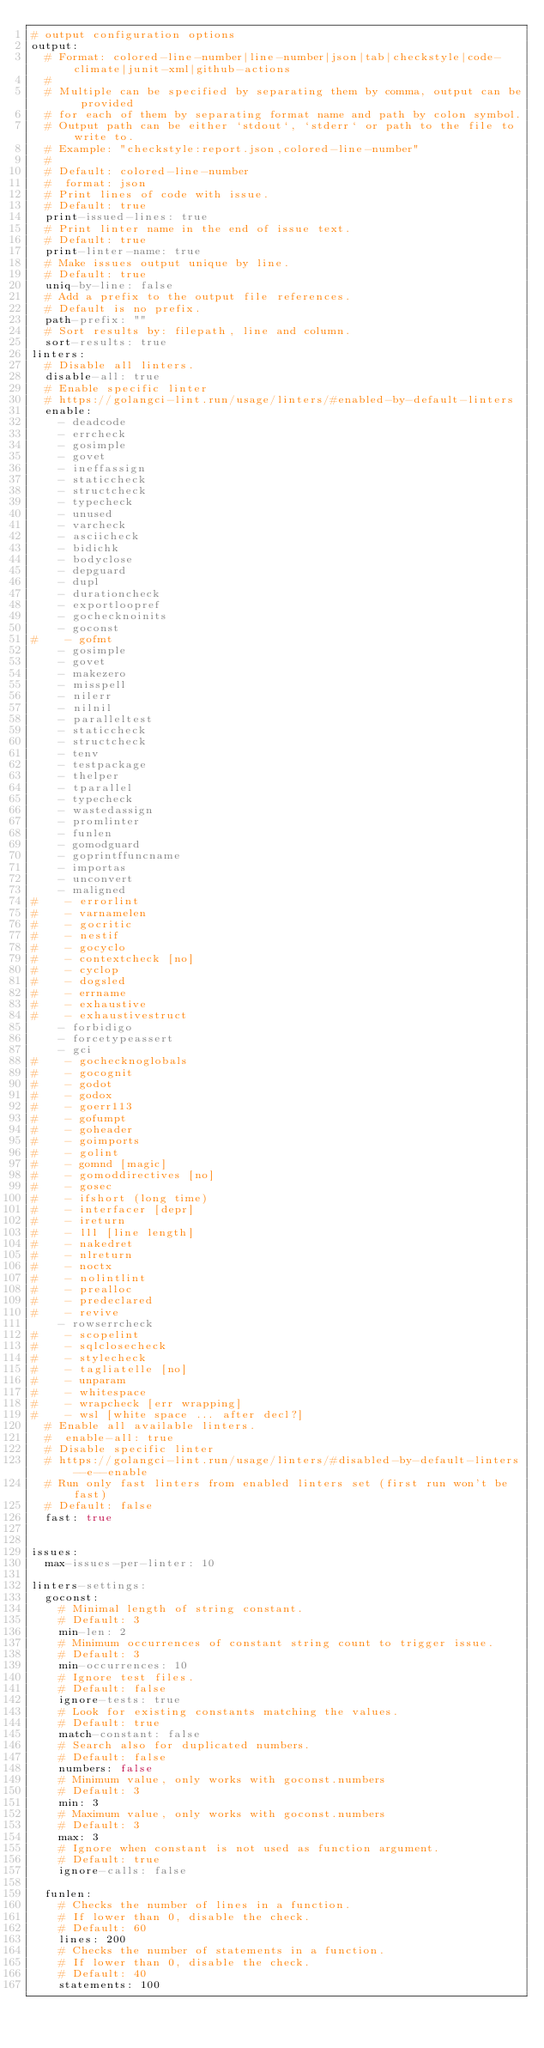<code> <loc_0><loc_0><loc_500><loc_500><_YAML_># output configuration options
output:
  # Format: colored-line-number|line-number|json|tab|checkstyle|code-climate|junit-xml|github-actions
  #
  # Multiple can be specified by separating them by comma, output can be provided
  # for each of them by separating format name and path by colon symbol.
  # Output path can be either `stdout`, `stderr` or path to the file to write to.
  # Example: "checkstyle:report.json,colored-line-number"
  #
  # Default: colored-line-number
  #  format: json
  # Print lines of code with issue.
  # Default: true
  print-issued-lines: true
  # Print linter name in the end of issue text.
  # Default: true
  print-linter-name: true
  # Make issues output unique by line.
  # Default: true
  uniq-by-line: false
  # Add a prefix to the output file references.
  # Default is no prefix.
  path-prefix: ""
  # Sort results by: filepath, line and column.
  sort-results: true
linters:
  # Disable all linters.
  disable-all: true
  # Enable specific linter
  # https://golangci-lint.run/usage/linters/#enabled-by-default-linters
  enable:
    - deadcode
    - errcheck
    - gosimple
    - govet
    - ineffassign
    - staticcheck
    - structcheck
    - typecheck
    - unused
    - varcheck
    - asciicheck
    - bidichk
    - bodyclose
    - depguard
    - dupl
    - durationcheck
    - exportloopref
    - gochecknoinits
    - goconst
#    - gofmt
    - gosimple
    - govet
    - makezero
    - misspell
    - nilerr
    - nilnil
    - paralleltest
    - staticcheck
    - structcheck
    - tenv
    - testpackage
    - thelper
    - tparallel
    - typecheck
    - wastedassign
    - promlinter
    - funlen
    - gomodguard
    - goprintffuncname
    - importas
    - unconvert
    - maligned
#    - errorlint
#    - varnamelen
#    - gocritic
#    - nestif
#    - gocyclo
#    - contextcheck [no]
#    - cyclop
#    - dogsled
#    - errname
#    - exhaustive
#    - exhaustivestruct
    - forbidigo
    - forcetypeassert
    - gci
#    - gochecknoglobals
#    - gocognit
#    - godot
#    - godox
#    - goerr113
#    - gofumpt
#    - goheader
#    - goimports
#    - golint
#    - gomnd [magic]
#    - gomoddirectives [no]
#    - gosec
#    - ifshort (long time)
#    - interfacer [depr]
#    - ireturn
#    - lll [line length]
#    - nakedret
#    - nlreturn
#    - noctx
#    - nolintlint
#    - prealloc
#    - predeclared
#    - revive
    - rowserrcheck
#    - scopelint
#    - sqlclosecheck
#    - stylecheck
#    - tagliatelle [no]
#    - unparam
#    - whitespace
#    - wrapcheck [err wrapping]
#    - wsl [white space ... after decl?]
  # Enable all available linters.
  #  enable-all: true
  # Disable specific linter
  # https://golangci-lint.run/usage/linters/#disabled-by-default-linters--e--enable
  # Run only fast linters from enabled linters set (first run won't be fast)
  # Default: false
  fast: true


issues:
  max-issues-per-linter: 10

linters-settings:
  goconst:
    # Minimal length of string constant.
    # Default: 3
    min-len: 2
    # Minimum occurrences of constant string count to trigger issue.
    # Default: 3
    min-occurrences: 10
    # Ignore test files.
    # Default: false
    ignore-tests: true
    # Look for existing constants matching the values.
    # Default: true
    match-constant: false
    # Search also for duplicated numbers.
    # Default: false
    numbers: false
    # Minimum value, only works with goconst.numbers
    # Default: 3
    min: 3
    # Maximum value, only works with goconst.numbers
    # Default: 3
    max: 3
    # Ignore when constant is not used as function argument.
    # Default: true
    ignore-calls: false

  funlen:
    # Checks the number of lines in a function.
    # If lower than 0, disable the check.
    # Default: 60
    lines: 200
    # Checks the number of statements in a function.
    # If lower than 0, disable the check.
    # Default: 40
    statements: 100</code> 